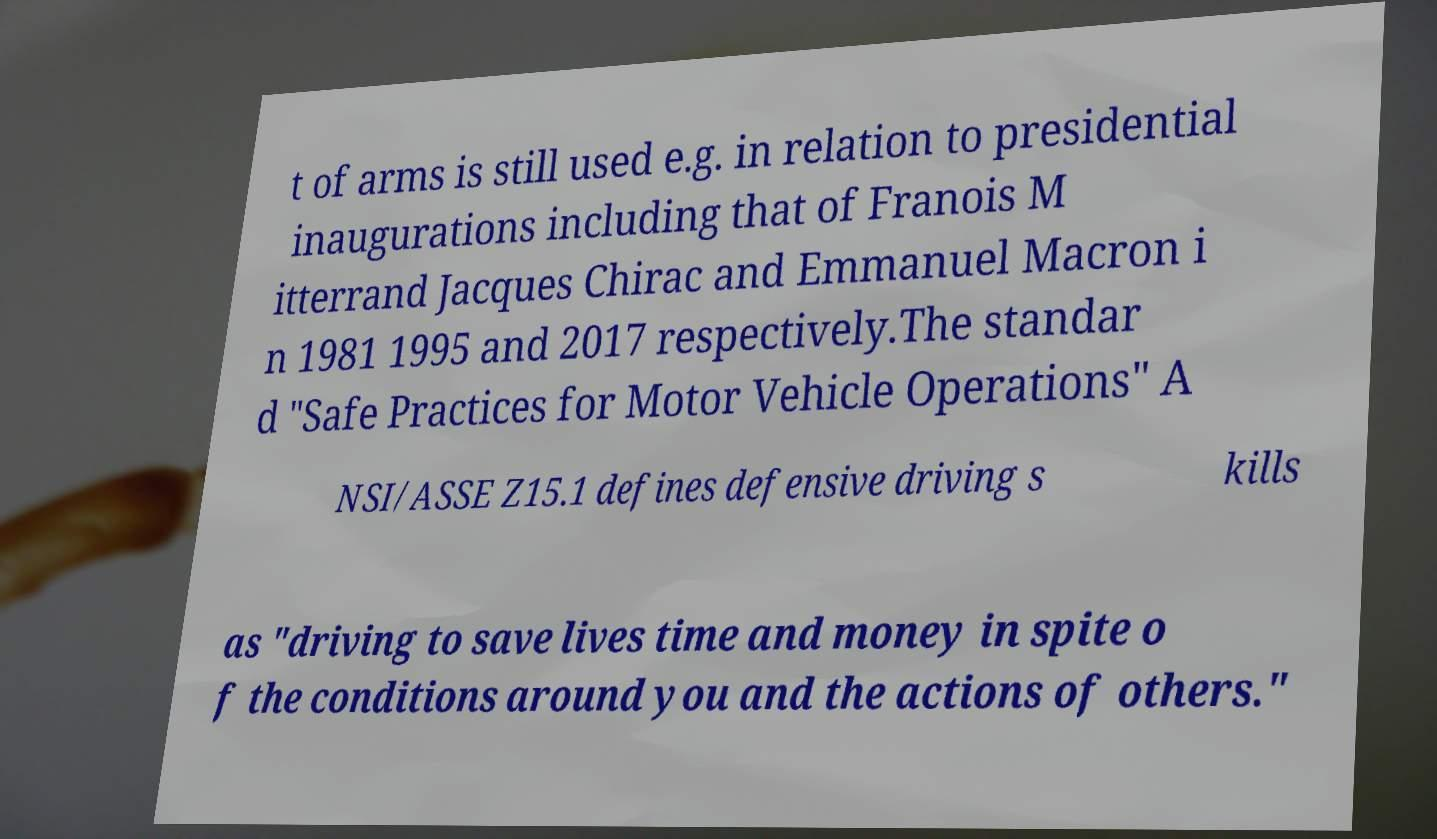Can you read and provide the text displayed in the image?This photo seems to have some interesting text. Can you extract and type it out for me? t of arms is still used e.g. in relation to presidential inaugurations including that of Franois M itterrand Jacques Chirac and Emmanuel Macron i n 1981 1995 and 2017 respectively.The standar d "Safe Practices for Motor Vehicle Operations" A NSI/ASSE Z15.1 defines defensive driving s kills as "driving to save lives time and money in spite o f the conditions around you and the actions of others." 